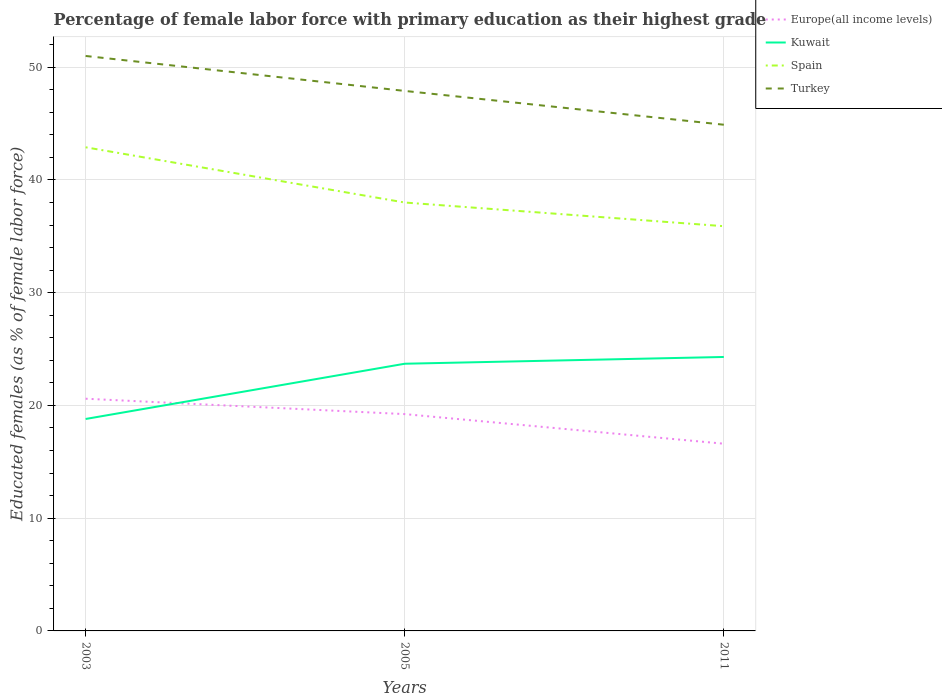Across all years, what is the maximum percentage of female labor force with primary education in Kuwait?
Ensure brevity in your answer.  18.8. In which year was the percentage of female labor force with primary education in Kuwait maximum?
Offer a terse response. 2003. What is the total percentage of female labor force with primary education in Turkey in the graph?
Your answer should be compact. 6.1. Is the percentage of female labor force with primary education in Europe(all income levels) strictly greater than the percentage of female labor force with primary education in Turkey over the years?
Offer a terse response. Yes. How many lines are there?
Ensure brevity in your answer.  4. How many years are there in the graph?
Provide a short and direct response. 3. Where does the legend appear in the graph?
Provide a succinct answer. Top right. What is the title of the graph?
Your answer should be compact. Percentage of female labor force with primary education as their highest grade. Does "Samoa" appear as one of the legend labels in the graph?
Your response must be concise. No. What is the label or title of the Y-axis?
Your answer should be compact. Educated females (as % of female labor force). What is the Educated females (as % of female labor force) of Europe(all income levels) in 2003?
Offer a very short reply. 20.6. What is the Educated females (as % of female labor force) of Kuwait in 2003?
Provide a succinct answer. 18.8. What is the Educated females (as % of female labor force) of Spain in 2003?
Your answer should be very brief. 42.9. What is the Educated females (as % of female labor force) of Europe(all income levels) in 2005?
Give a very brief answer. 19.23. What is the Educated females (as % of female labor force) of Kuwait in 2005?
Your response must be concise. 23.7. What is the Educated females (as % of female labor force) of Turkey in 2005?
Provide a short and direct response. 47.9. What is the Educated females (as % of female labor force) in Europe(all income levels) in 2011?
Your response must be concise. 16.61. What is the Educated females (as % of female labor force) of Kuwait in 2011?
Provide a short and direct response. 24.3. What is the Educated females (as % of female labor force) of Spain in 2011?
Offer a very short reply. 35.9. What is the Educated females (as % of female labor force) of Turkey in 2011?
Provide a short and direct response. 44.9. Across all years, what is the maximum Educated females (as % of female labor force) of Europe(all income levels)?
Offer a very short reply. 20.6. Across all years, what is the maximum Educated females (as % of female labor force) of Kuwait?
Provide a short and direct response. 24.3. Across all years, what is the maximum Educated females (as % of female labor force) in Spain?
Provide a short and direct response. 42.9. Across all years, what is the minimum Educated females (as % of female labor force) in Europe(all income levels)?
Give a very brief answer. 16.61. Across all years, what is the minimum Educated females (as % of female labor force) of Kuwait?
Your answer should be very brief. 18.8. Across all years, what is the minimum Educated females (as % of female labor force) of Spain?
Provide a short and direct response. 35.9. Across all years, what is the minimum Educated females (as % of female labor force) of Turkey?
Provide a succinct answer. 44.9. What is the total Educated females (as % of female labor force) in Europe(all income levels) in the graph?
Offer a terse response. 56.43. What is the total Educated females (as % of female labor force) of Kuwait in the graph?
Provide a succinct answer. 66.8. What is the total Educated females (as % of female labor force) of Spain in the graph?
Give a very brief answer. 116.8. What is the total Educated females (as % of female labor force) of Turkey in the graph?
Provide a short and direct response. 143.8. What is the difference between the Educated females (as % of female labor force) in Europe(all income levels) in 2003 and that in 2005?
Offer a terse response. 1.37. What is the difference between the Educated females (as % of female labor force) of Kuwait in 2003 and that in 2005?
Ensure brevity in your answer.  -4.9. What is the difference between the Educated females (as % of female labor force) of Spain in 2003 and that in 2005?
Offer a terse response. 4.9. What is the difference between the Educated females (as % of female labor force) of Europe(all income levels) in 2003 and that in 2011?
Provide a short and direct response. 3.99. What is the difference between the Educated females (as % of female labor force) in Spain in 2003 and that in 2011?
Give a very brief answer. 7. What is the difference between the Educated females (as % of female labor force) in Europe(all income levels) in 2005 and that in 2011?
Keep it short and to the point. 2.63. What is the difference between the Educated females (as % of female labor force) of Turkey in 2005 and that in 2011?
Your response must be concise. 3. What is the difference between the Educated females (as % of female labor force) in Europe(all income levels) in 2003 and the Educated females (as % of female labor force) in Kuwait in 2005?
Keep it short and to the point. -3.1. What is the difference between the Educated females (as % of female labor force) in Europe(all income levels) in 2003 and the Educated females (as % of female labor force) in Spain in 2005?
Your response must be concise. -17.4. What is the difference between the Educated females (as % of female labor force) of Europe(all income levels) in 2003 and the Educated females (as % of female labor force) of Turkey in 2005?
Your answer should be compact. -27.3. What is the difference between the Educated females (as % of female labor force) of Kuwait in 2003 and the Educated females (as % of female labor force) of Spain in 2005?
Make the answer very short. -19.2. What is the difference between the Educated females (as % of female labor force) of Kuwait in 2003 and the Educated females (as % of female labor force) of Turkey in 2005?
Give a very brief answer. -29.1. What is the difference between the Educated females (as % of female labor force) in Europe(all income levels) in 2003 and the Educated females (as % of female labor force) in Kuwait in 2011?
Ensure brevity in your answer.  -3.7. What is the difference between the Educated females (as % of female labor force) of Europe(all income levels) in 2003 and the Educated females (as % of female labor force) of Spain in 2011?
Provide a short and direct response. -15.3. What is the difference between the Educated females (as % of female labor force) of Europe(all income levels) in 2003 and the Educated females (as % of female labor force) of Turkey in 2011?
Make the answer very short. -24.3. What is the difference between the Educated females (as % of female labor force) in Kuwait in 2003 and the Educated females (as % of female labor force) in Spain in 2011?
Offer a very short reply. -17.1. What is the difference between the Educated females (as % of female labor force) in Kuwait in 2003 and the Educated females (as % of female labor force) in Turkey in 2011?
Ensure brevity in your answer.  -26.1. What is the difference between the Educated females (as % of female labor force) of Spain in 2003 and the Educated females (as % of female labor force) of Turkey in 2011?
Give a very brief answer. -2. What is the difference between the Educated females (as % of female labor force) of Europe(all income levels) in 2005 and the Educated females (as % of female labor force) of Kuwait in 2011?
Offer a very short reply. -5.07. What is the difference between the Educated females (as % of female labor force) in Europe(all income levels) in 2005 and the Educated females (as % of female labor force) in Spain in 2011?
Give a very brief answer. -16.67. What is the difference between the Educated females (as % of female labor force) in Europe(all income levels) in 2005 and the Educated females (as % of female labor force) in Turkey in 2011?
Provide a succinct answer. -25.67. What is the difference between the Educated females (as % of female labor force) in Kuwait in 2005 and the Educated females (as % of female labor force) in Turkey in 2011?
Offer a terse response. -21.2. What is the average Educated females (as % of female labor force) of Europe(all income levels) per year?
Provide a short and direct response. 18.81. What is the average Educated females (as % of female labor force) in Kuwait per year?
Your answer should be compact. 22.27. What is the average Educated females (as % of female labor force) of Spain per year?
Keep it short and to the point. 38.93. What is the average Educated females (as % of female labor force) of Turkey per year?
Provide a succinct answer. 47.93. In the year 2003, what is the difference between the Educated females (as % of female labor force) of Europe(all income levels) and Educated females (as % of female labor force) of Kuwait?
Your answer should be very brief. 1.8. In the year 2003, what is the difference between the Educated females (as % of female labor force) of Europe(all income levels) and Educated females (as % of female labor force) of Spain?
Provide a short and direct response. -22.3. In the year 2003, what is the difference between the Educated females (as % of female labor force) of Europe(all income levels) and Educated females (as % of female labor force) of Turkey?
Provide a short and direct response. -30.4. In the year 2003, what is the difference between the Educated females (as % of female labor force) in Kuwait and Educated females (as % of female labor force) in Spain?
Your answer should be very brief. -24.1. In the year 2003, what is the difference between the Educated females (as % of female labor force) of Kuwait and Educated females (as % of female labor force) of Turkey?
Keep it short and to the point. -32.2. In the year 2003, what is the difference between the Educated females (as % of female labor force) of Spain and Educated females (as % of female labor force) of Turkey?
Keep it short and to the point. -8.1. In the year 2005, what is the difference between the Educated females (as % of female labor force) in Europe(all income levels) and Educated females (as % of female labor force) in Kuwait?
Your response must be concise. -4.47. In the year 2005, what is the difference between the Educated females (as % of female labor force) of Europe(all income levels) and Educated females (as % of female labor force) of Spain?
Give a very brief answer. -18.77. In the year 2005, what is the difference between the Educated females (as % of female labor force) in Europe(all income levels) and Educated females (as % of female labor force) in Turkey?
Provide a succinct answer. -28.67. In the year 2005, what is the difference between the Educated females (as % of female labor force) of Kuwait and Educated females (as % of female labor force) of Spain?
Your response must be concise. -14.3. In the year 2005, what is the difference between the Educated females (as % of female labor force) in Kuwait and Educated females (as % of female labor force) in Turkey?
Provide a short and direct response. -24.2. In the year 2011, what is the difference between the Educated females (as % of female labor force) of Europe(all income levels) and Educated females (as % of female labor force) of Kuwait?
Your response must be concise. -7.69. In the year 2011, what is the difference between the Educated females (as % of female labor force) in Europe(all income levels) and Educated females (as % of female labor force) in Spain?
Keep it short and to the point. -19.29. In the year 2011, what is the difference between the Educated females (as % of female labor force) in Europe(all income levels) and Educated females (as % of female labor force) in Turkey?
Your response must be concise. -28.29. In the year 2011, what is the difference between the Educated females (as % of female labor force) in Kuwait and Educated females (as % of female labor force) in Turkey?
Give a very brief answer. -20.6. In the year 2011, what is the difference between the Educated females (as % of female labor force) of Spain and Educated females (as % of female labor force) of Turkey?
Provide a succinct answer. -9. What is the ratio of the Educated females (as % of female labor force) in Europe(all income levels) in 2003 to that in 2005?
Offer a terse response. 1.07. What is the ratio of the Educated females (as % of female labor force) in Kuwait in 2003 to that in 2005?
Your answer should be very brief. 0.79. What is the ratio of the Educated females (as % of female labor force) in Spain in 2003 to that in 2005?
Keep it short and to the point. 1.13. What is the ratio of the Educated females (as % of female labor force) of Turkey in 2003 to that in 2005?
Provide a succinct answer. 1.06. What is the ratio of the Educated females (as % of female labor force) of Europe(all income levels) in 2003 to that in 2011?
Give a very brief answer. 1.24. What is the ratio of the Educated females (as % of female labor force) in Kuwait in 2003 to that in 2011?
Make the answer very short. 0.77. What is the ratio of the Educated females (as % of female labor force) of Spain in 2003 to that in 2011?
Offer a terse response. 1.2. What is the ratio of the Educated females (as % of female labor force) of Turkey in 2003 to that in 2011?
Make the answer very short. 1.14. What is the ratio of the Educated females (as % of female labor force) of Europe(all income levels) in 2005 to that in 2011?
Your response must be concise. 1.16. What is the ratio of the Educated females (as % of female labor force) of Kuwait in 2005 to that in 2011?
Your answer should be compact. 0.98. What is the ratio of the Educated females (as % of female labor force) in Spain in 2005 to that in 2011?
Make the answer very short. 1.06. What is the ratio of the Educated females (as % of female labor force) of Turkey in 2005 to that in 2011?
Keep it short and to the point. 1.07. What is the difference between the highest and the second highest Educated females (as % of female labor force) in Europe(all income levels)?
Make the answer very short. 1.37. What is the difference between the highest and the lowest Educated females (as % of female labor force) in Europe(all income levels)?
Your answer should be compact. 3.99. What is the difference between the highest and the lowest Educated females (as % of female labor force) in Kuwait?
Your answer should be very brief. 5.5. 